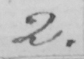Can you read and transcribe this handwriting? 2 . 